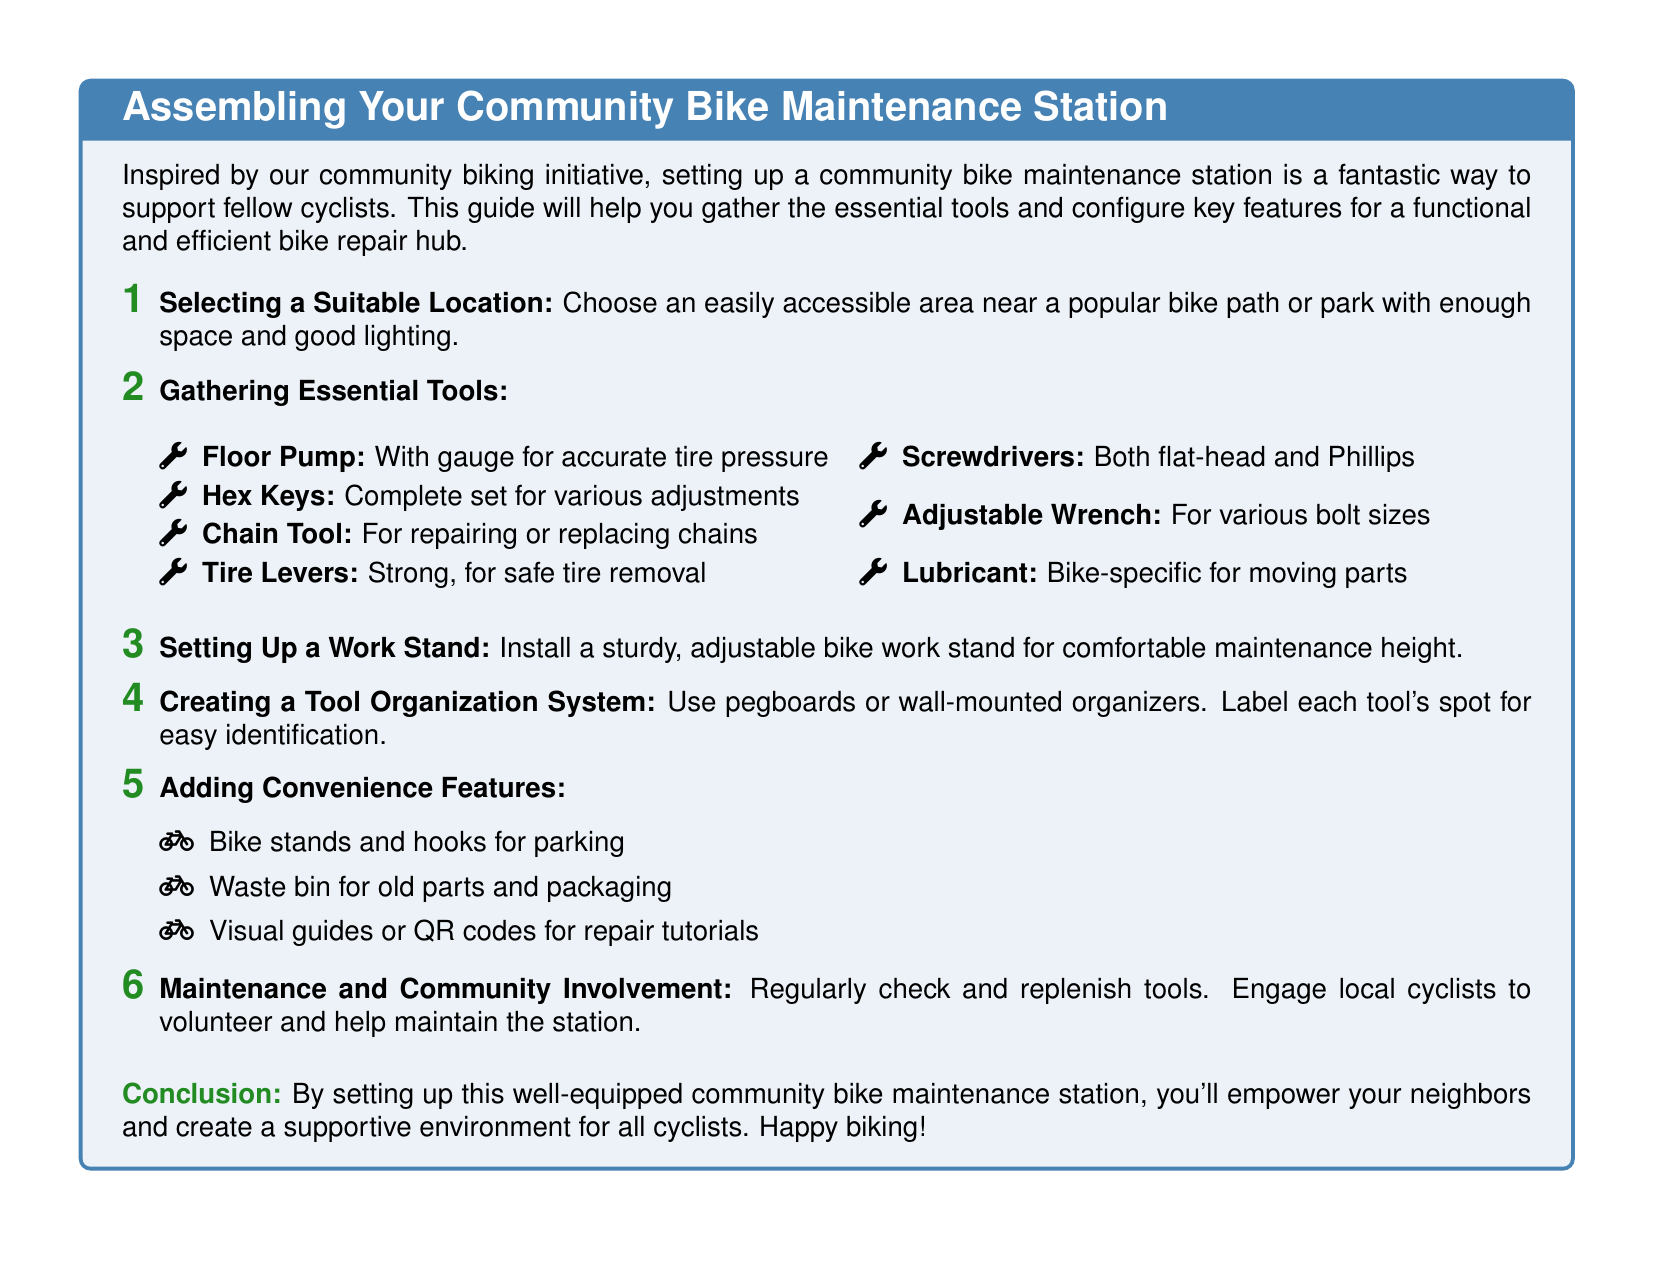What is the first step in assembling the station? The first step is to select a suitable location that is easily accessible and well-lit.
Answer: Selecting a Suitable Location How many essential tools are listed? There are seven essential tools listed in the document.
Answer: 7 What feature is recommended for organizing tools? The document recommends using pegboards or wall-mounted organizers for tool organization.
Answer: Pegboards What type of pump is needed? The document specifies needing a floor pump with a gauge for accurate tire pressure.
Answer: Floor Pump What additional feature is suggested for waste management? The document suggests adding a waste bin for old parts and packaging.
Answer: Waste bin What is the primary purpose of the bike maintenance station? The primary purpose is to empower neighbors and support cyclists in the community.
Answer: Empower neighbors How often should tools be checked and replenished? The document indicates that tools should be regularly checked and replenished.
Answer: Regularly What is one type of visual aid recommended? The document mentions using visual guides or QR codes for repair tutorials as a visual aid.
Answer: Visual guides 